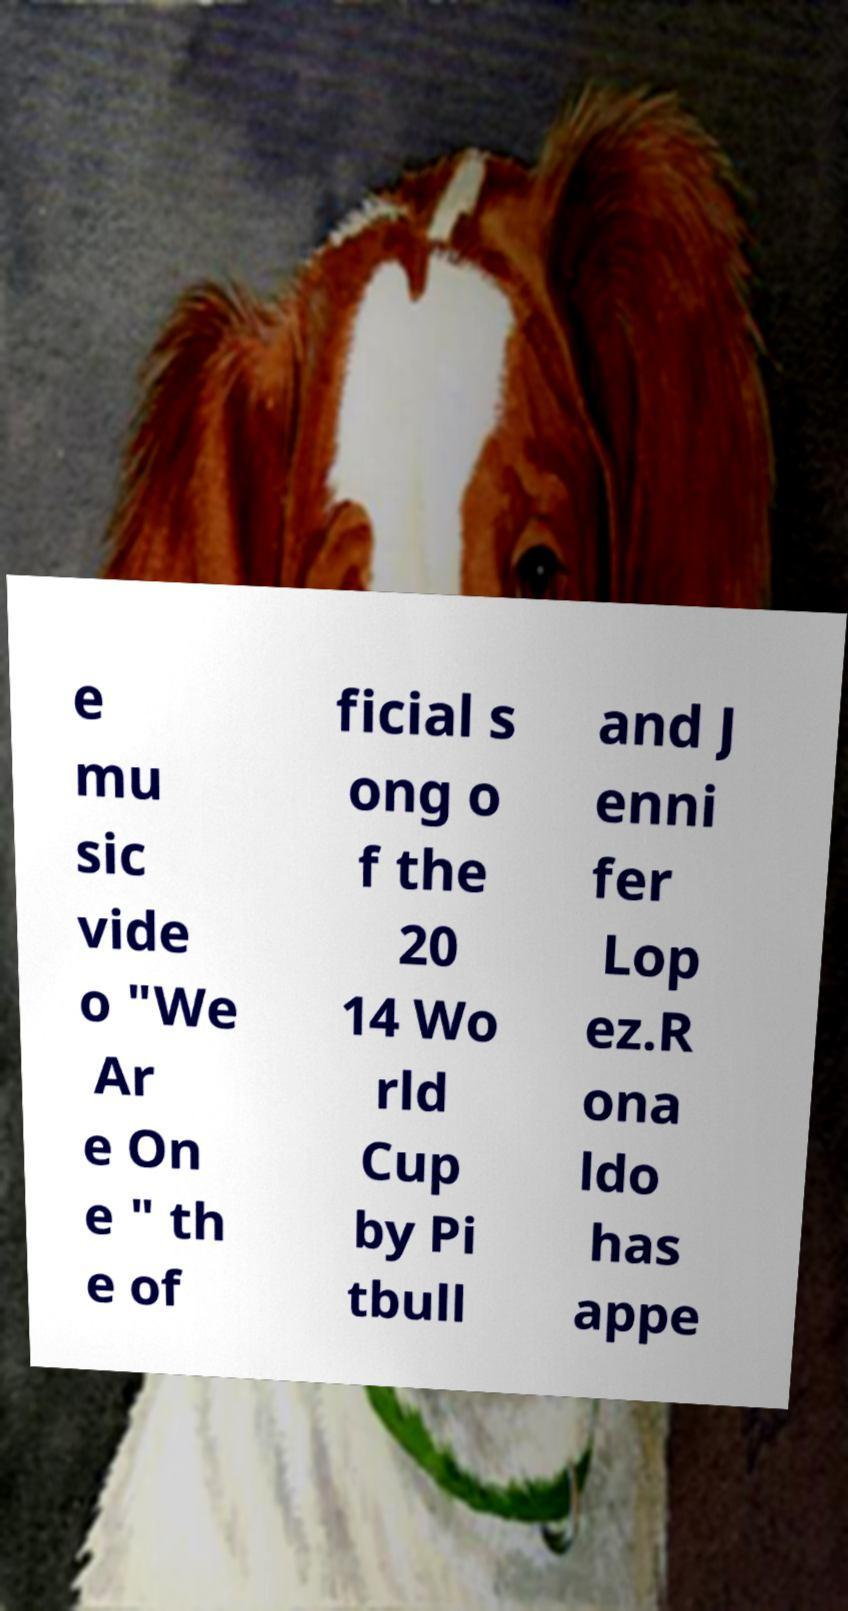Can you accurately transcribe the text from the provided image for me? e mu sic vide o "We Ar e On e " th e of ficial s ong o f the 20 14 Wo rld Cup by Pi tbull and J enni fer Lop ez.R ona ldo has appe 